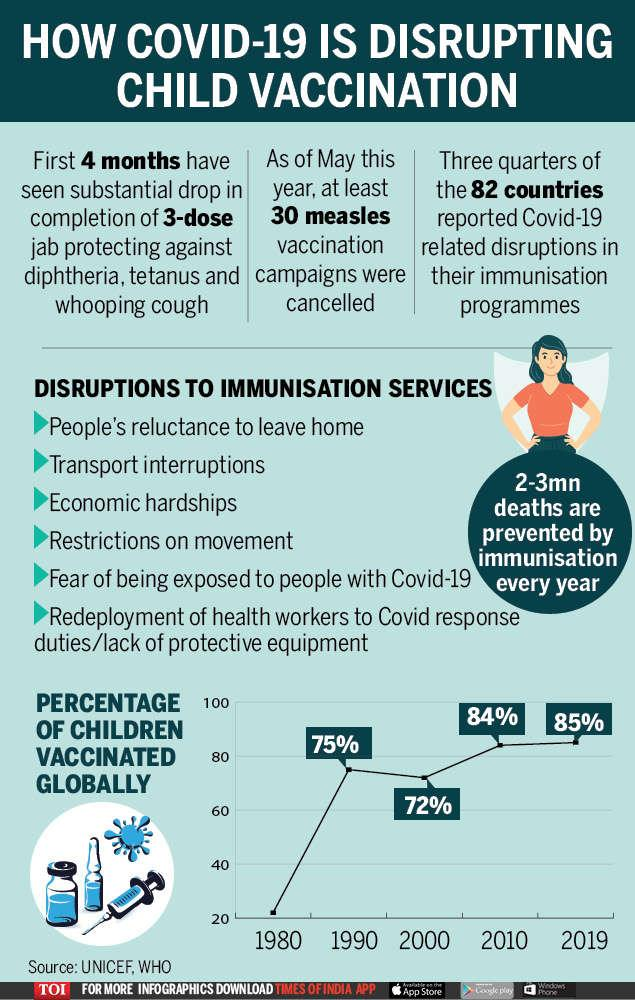Point out several critical features in this image. In approximately the year 2000, there was a slight decrease in the percentage of children worldwide who had received vaccinations. Disruptions to immunization services are often caused by multiple factors. Six specific reasons for disruptions have been listed. Economic hardships are the third reason given for disrupting vaccination services. The fifth reason given for disruption in vaccination services is the fear of being exposed to individuals with Covid-19. As per the infographic, immunisation services were disrupted or delayed due to restrictions on movement. 